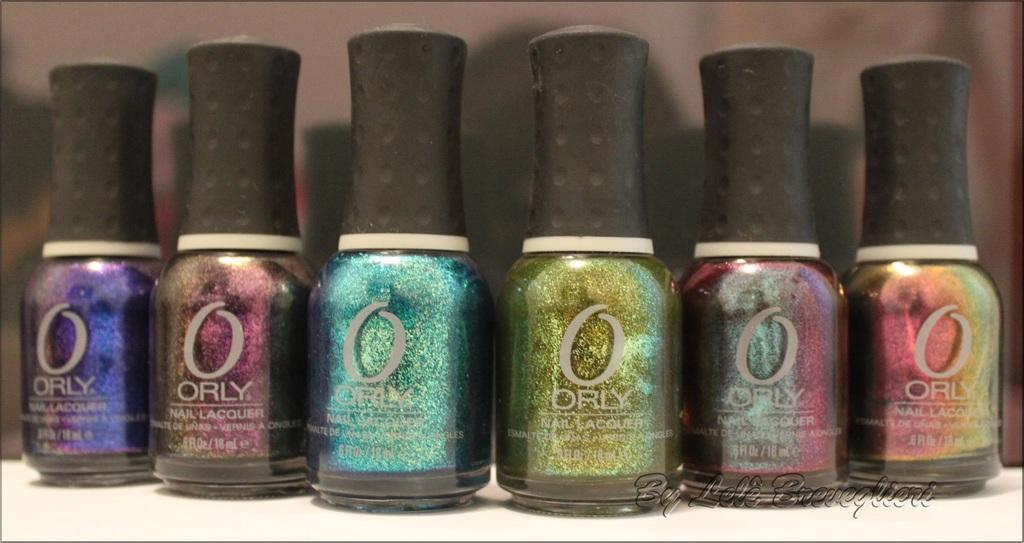What objects are visible in the image? There are bottles in the image. What is the color of the surface on which the bottles are placed? The bottles are on a white surface. Is there any text visible in the image? Yes, there is text in the bottom right of the image. What type of punishment is being depicted in the image? There is no punishment being depicted in the image; it features bottles on a white surface with text in the bottom right. 